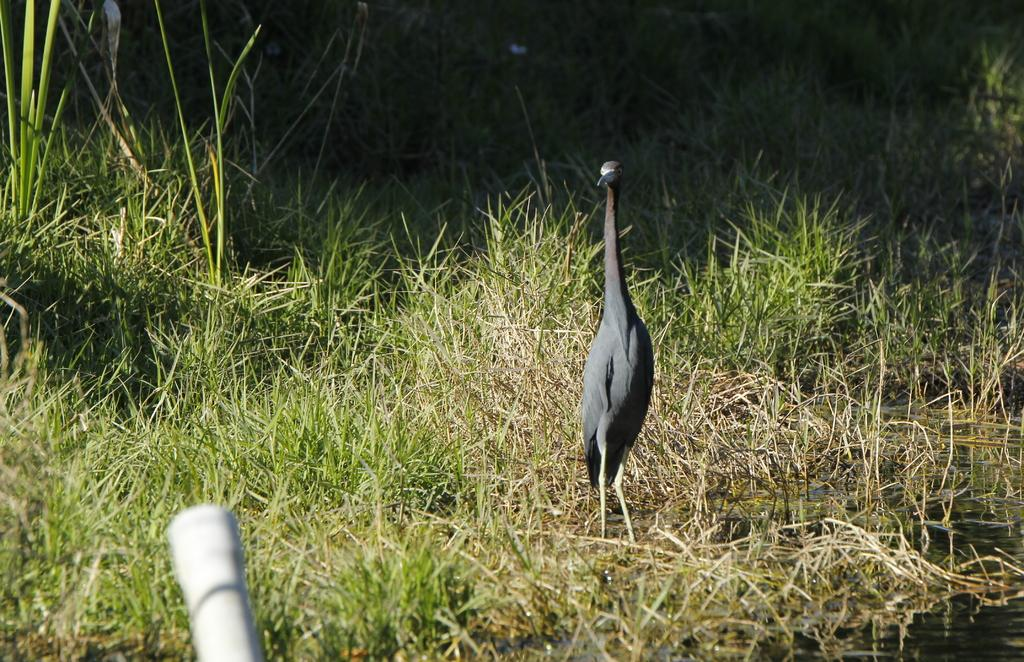What type of animal is in the image? There is a black color bird in the image. What type of vegetation is visible in the image? There is green grass visible in the image. What else is visible in the image besides the bird and grass? There is water visible in the image. What type of pickle is being served for dinner in the image? There is no dinner or pickle present in the image. Can you see a plane flying in the sky in the image? There is no plane visible in the image. 